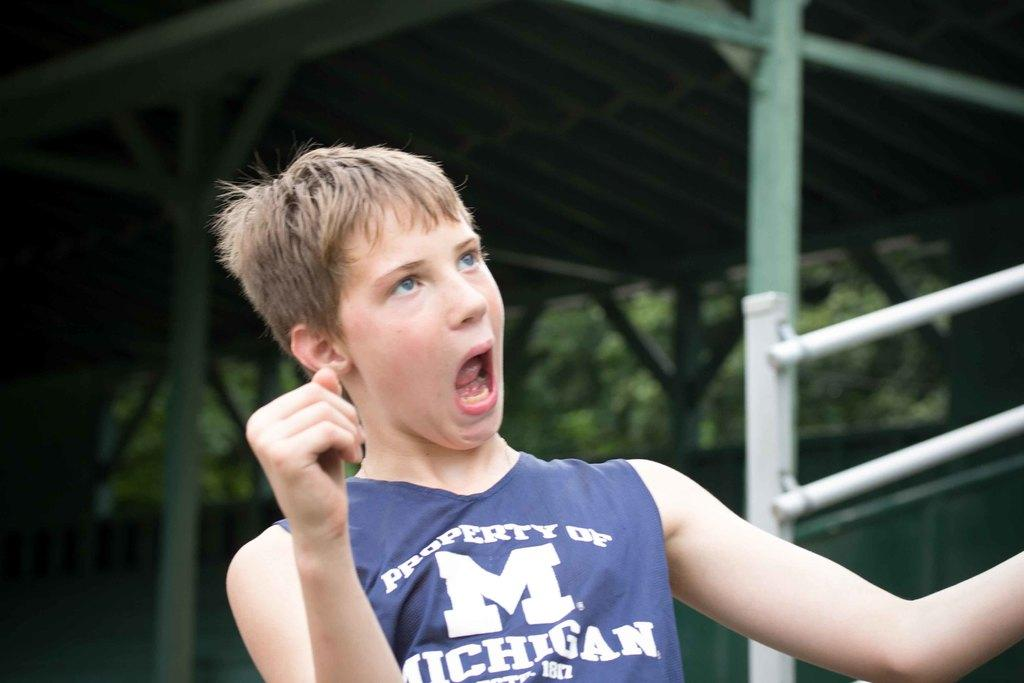<image>
Render a clear and concise summary of the photo. A young boy wearing a Property of Michigan tank top is making a funny face. 